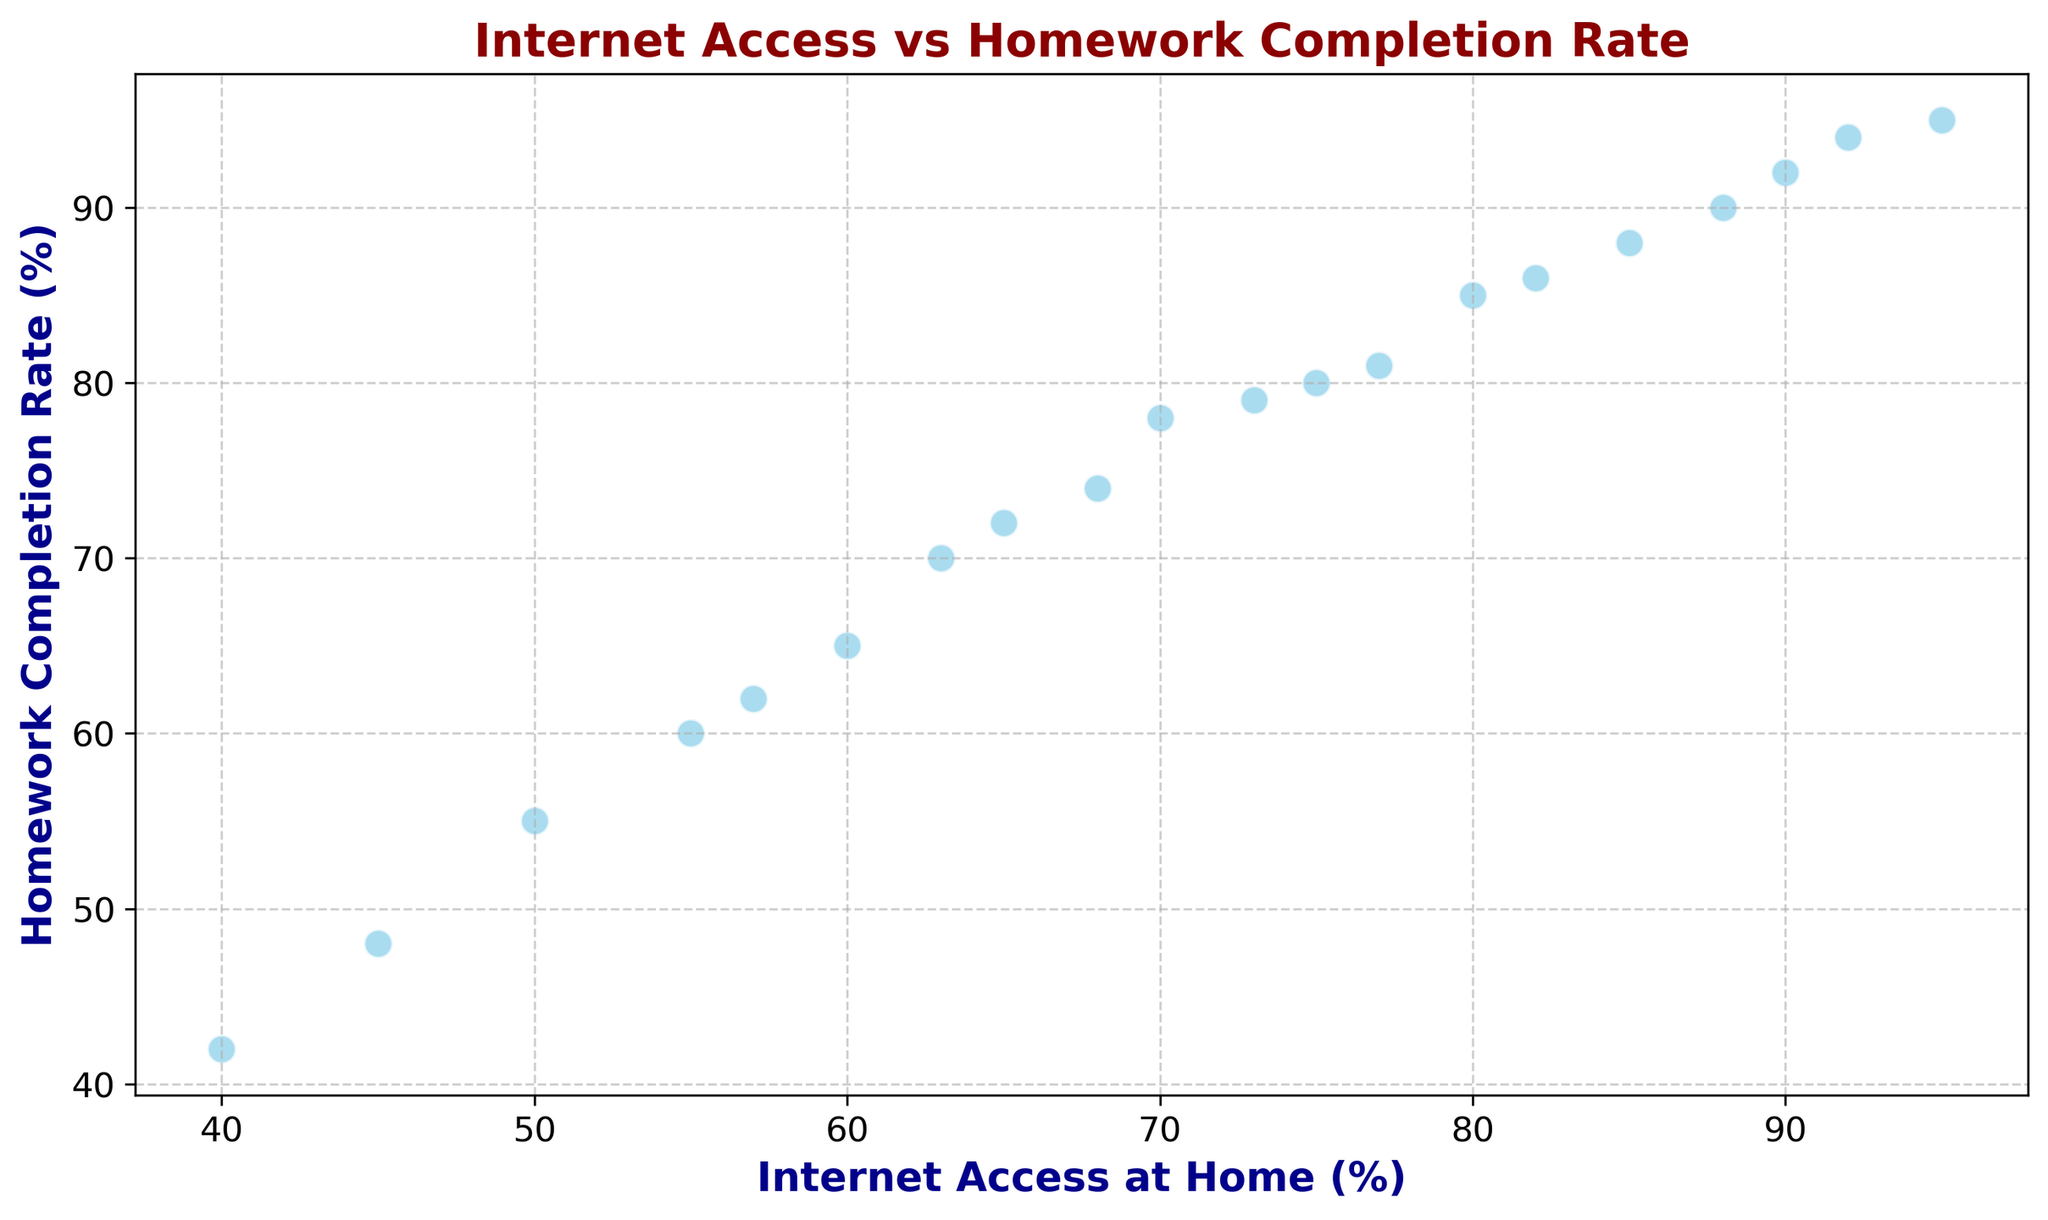Which data point has the highest Internet access? Look for the data point where the x-value (Internet Access) is the highest. In this case, it's at (95, 95).
Answer: (95, 95) What is the range of Homework Completion Rates on the chart? Identify the maximum and minimum y-values (Homework Completion Rates) on the chart. The maximum is 95 and the minimum is 42. Subtract the minimum from the maximum (95 - 42) to find the range.
Answer: 53 How does Homework Completion Rate change with Internet Access? Observe the overall trend of the scatter plot. As Internet Access increases from 40% to 95%, the Homework Completion Rate generally increases, indicating a positive correlation.
Answer: Positive correlation Which data point has the lowest Homework Completion Rate? Find the data point where the y-value (Homework Completion Rate) is the lowest. In this case, it is at (40, 42).
Answer: (40, 42) What is the average Homework Completion Rate for data points with Internet Access greater than 80%? Identify the data points where Internet Access is greater than 80%: (90, 92), (85, 88), (95, 95), (82, 86), (92, 94), (88, 90). Add the y-values of these points (92+88+95+86+94+90) and divide by the number of points (6). (92+88+95+86+94+90)/6 = 90.83 (approximately).
Answer: 90.83 Are there any outliers in the scatter plot? Examine the scatter plot for any data points that are significantly different from the rest. All points appear to follow the general trend without any data points standing out as outliers.
Answer: No What is the difference in Homework Completion Rate between the data point with 70% Internet Access and the data point with 50% Internet Access? Locate the y-values for Internet Access at 70% (78) and 50% (55). Subtract 55 from 78 (78-55) to find the difference.
Answer: 23 For Internet Access between 60% and 80%, what is the average Homework Completion Rate? Identify the data points within 60% to 80% Internet Access: (70, 78), (75, 80), (60, 65), (65, 72), (77, 81), (68, 74), (73, 79). Sum the y-values (78+80+65+72+81+74+79) and divide by the number of points (7). (78+80+65+72+81+74+79)/7 ≈ 75.57
Answer: 75.57 How many data points have both Internet Access and Homework Completion Rate above 80%? Count the data points where both the x-value (Internet Access) and y-value (Homework Completion Rate) are above 80%. These points are: (90, 92), (85, 88), (95, 95), (82, 86), (92, 94), (88, 90). There are 6 points.
Answer: 6 Which data point has nearly equal values for Internet Access and Homework Completion Rate? Find the data point where the x-value and y-value are close to each other. The point (95, 95) has exactly equal values.
Answer: (95, 95) 